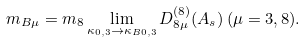<formula> <loc_0><loc_0><loc_500><loc_500>m _ { B \mu } = m _ { 8 } \lim _ { \kappa _ { 0 , 3 } \rightarrow \kappa _ { B 0 , 3 } } { D ^ { ( 8 ) } _ { 8 \mu } ( A _ { s } ) } \, ( \mu = 3 , 8 ) . \\</formula> 